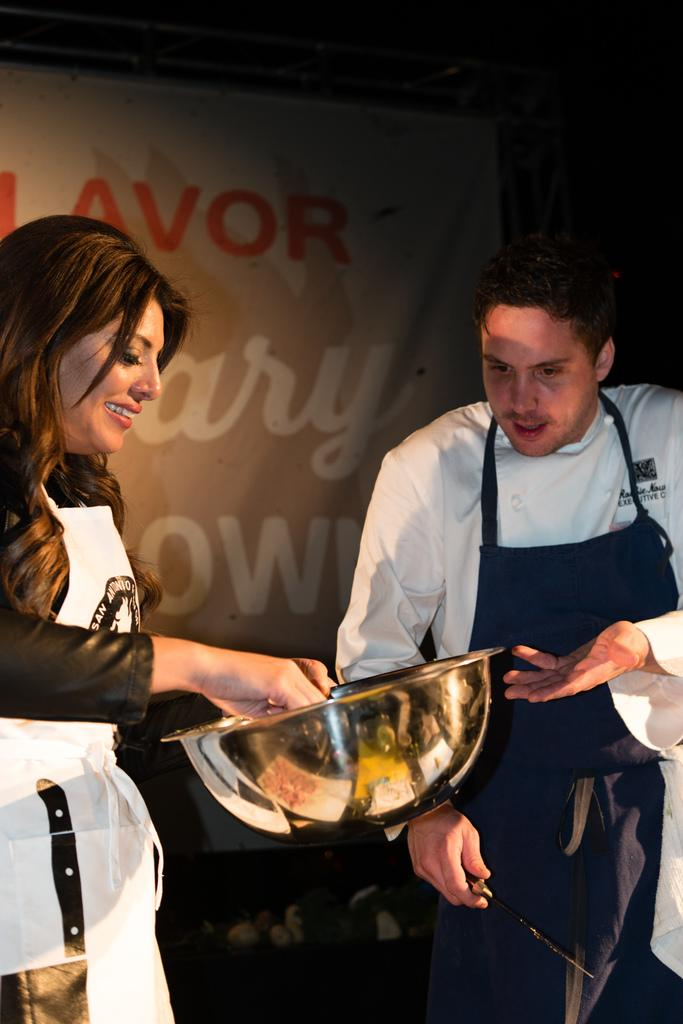How many people are in the image? There are two people in the image: a man and a woman. What is the woman holding in her hand? The woman is holding a dish in her hand. What is the man holding in his hand? The man is holding a knife. What can be seen in the background of the image? There is a banner in the background with some text. What type of chalk is the woman using to write on the jar in the image? There is no jar or chalk present in the image. 